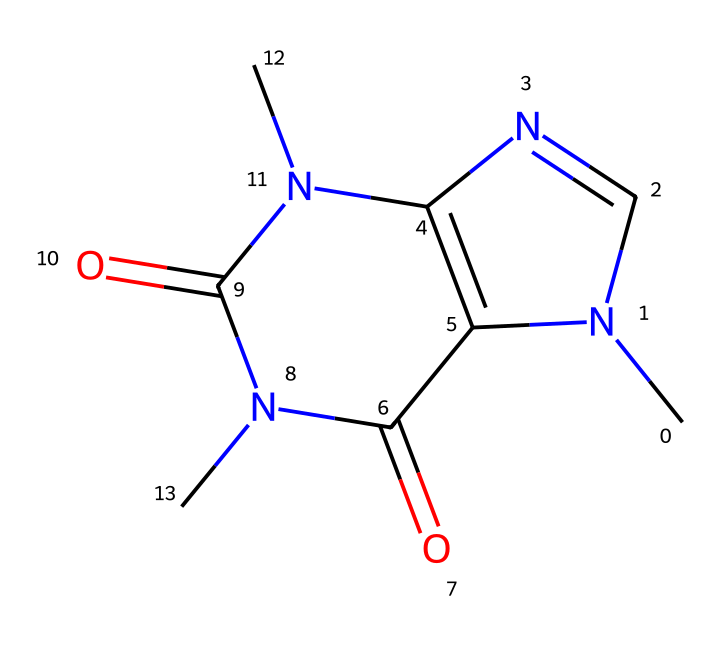What is the molecular formula of caffeine? The structure can be analyzed by counting the number of each type of atom present. In this case, the SMILES shows 8 carbon atoms (C), 10 hydrogen atoms (H), 4 nitrogen atoms (N), and 2 oxygen atoms (O). Therefore, the molecular formula is derived by summing these counts.
Answer: C8H10N4O2 How many rings are present in the structure of caffeine? By examining the chemical structure, we can identify the cyclic components. There are two fused rings in the structure, which are clearly marked by the notation in the SMILES string. Thus, there are two ring structures present.
Answer: 2 Which functional groups are present in caffeine? The structure of caffeine shows both amine groups (-NH) and carbonyl groups (C=O). Identifying these groups involves recognizing the specific arrangements of nitrogen and oxygen within the structure. Therefore, caffeine contains amine and carbonyl groups.
Answer: amine and carbonyl Does caffeine contain aromaticity? Aromatic compounds are typically characterized by cyclic structures with alternating double bonds and adhere to Huckel's rule. In the structure of caffeine, there are aromatic characteristics due to the presence of a nitrogen in a ring system that showcases resonance stability. Therefore, it can be concluded that caffeine exhibits aromatic properties.
Answer: yes What is the charge of caffeine at physiological pH? Analyzing the nitrogen atoms in caffeine reveals that under physiological pH (approximately 7.4), most nitrogen atoms in this structure retain a neutral charge. Thus, the overall charge of caffeine does not reflect any ionization under these conditions.
Answer: neutral 